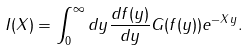<formula> <loc_0><loc_0><loc_500><loc_500>I ( X ) = \int _ { 0 } ^ { \infty } d y \frac { d f ( y ) } { d y } G ( f ( y ) ) e ^ { - X y } .</formula> 